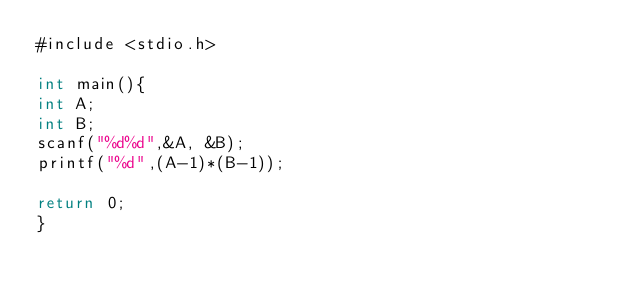<code> <loc_0><loc_0><loc_500><loc_500><_C#_>#include <stdio.h>

int main(){
int A;
int B;
scanf("%d%d",&A, &B);
printf("%d",(A-1)*(B-1));

return 0;
}</code> 